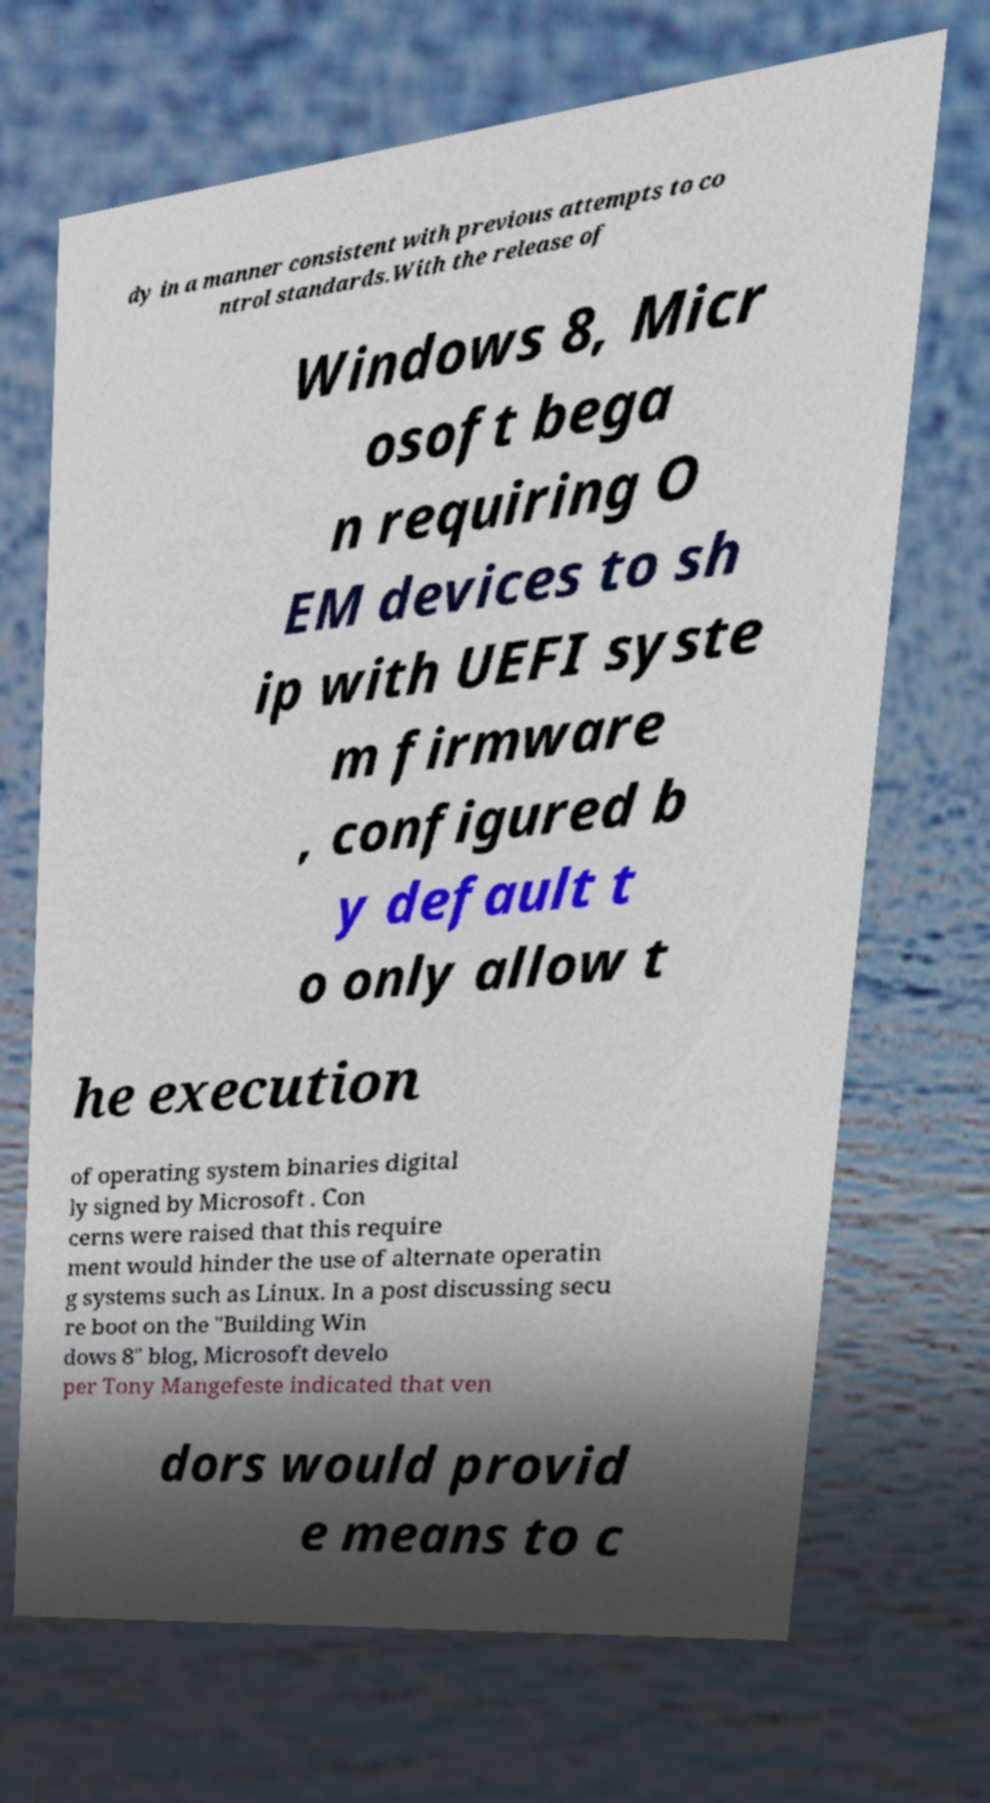Please read and relay the text visible in this image. What does it say? dy in a manner consistent with previous attempts to co ntrol standards.With the release of Windows 8, Micr osoft bega n requiring O EM devices to sh ip with UEFI syste m firmware , configured b y default t o only allow t he execution of operating system binaries digital ly signed by Microsoft . Con cerns were raised that this require ment would hinder the use of alternate operatin g systems such as Linux. In a post discussing secu re boot on the "Building Win dows 8" blog, Microsoft develo per Tony Mangefeste indicated that ven dors would provid e means to c 